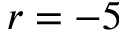<formula> <loc_0><loc_0><loc_500><loc_500>r = - 5</formula> 